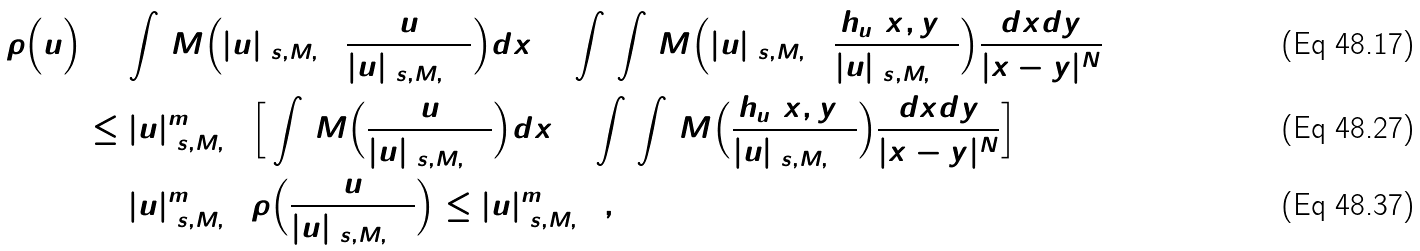Convert formula to latex. <formula><loc_0><loc_0><loc_500><loc_500>\tilde { \rho } \Big { ( } u \Big { ) } & = \int _ { \Omega } M \Big { ( } | u | _ { ( s , M , \Omega ) } \frac { u } { | u | _ { ( s , M , \Omega ) } } \Big { ) } d x + \int _ { \Omega } \int _ { \Omega } M \Big { ( } | u | _ { ( s , M , \Omega ) } \frac { h _ { u } ( x , y ) } { | u | _ { ( s , M , \Omega ) } } \Big { ) } \frac { d x d y } { | x - y | ^ { N } } \\ & \leq | u | _ { ( s , M , \Omega ) } ^ { m ^ { 0 } } \Big { [ } \int _ { \Omega } M \Big { ( } \frac { u } { | u | _ { ( s , M , \Omega ) } } \Big { ) } d x + \int _ { \Omega } \int _ { \Omega } M \Big { ( } \frac { h _ { u } ( x , y ) } { | u | _ { ( s , M , \Omega ) } } \Big { ) } \frac { d x d y } { | x - y | ^ { N } } \Big { ] } \\ & = | u | _ { ( s , M , \Omega ) } ^ { m ^ { 0 } } \tilde { \rho } \Big { ( } \frac { u } { | u | _ { ( s , M , \Omega ) } } \Big { ) } \leq | u | _ { ( s , M , \Omega ) } ^ { m ^ { 0 } } ,</formula> 